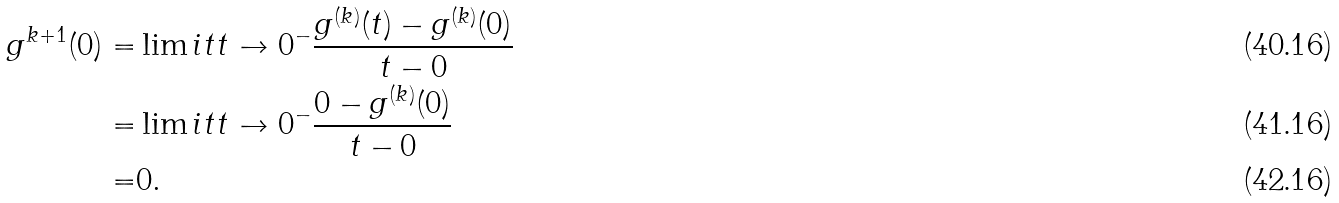<formula> <loc_0><loc_0><loc_500><loc_500>g ^ { k + 1 } ( 0 ) = & \lim i t { t \to 0 ^ { - } } \frac { g ^ { ( k ) } ( t ) - g ^ { ( k ) } ( 0 ) } { t - 0 } \\ = & \lim i t { t \to 0 ^ { - } } \frac { 0 - g ^ { ( k ) } ( 0 ) } { t - 0 } \\ = & 0 .</formula> 